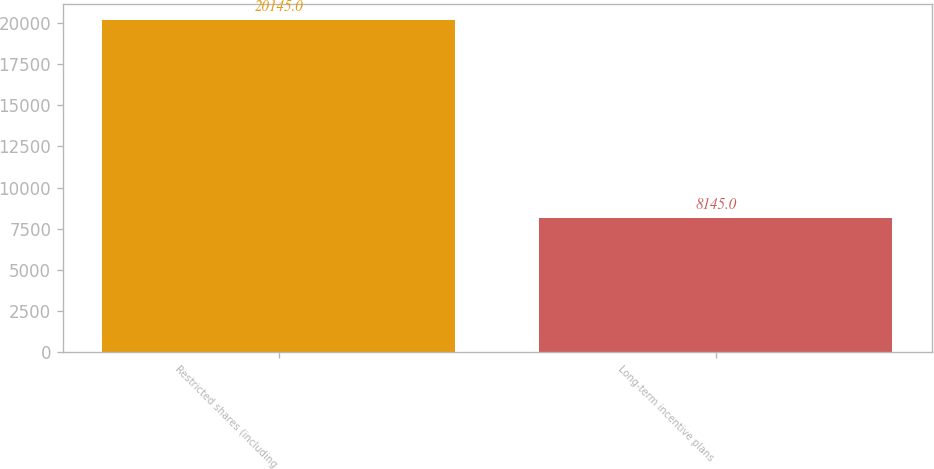Convert chart. <chart><loc_0><loc_0><loc_500><loc_500><bar_chart><fcel>Restricted shares (including<fcel>Long-term incentive plans<nl><fcel>20145<fcel>8145<nl></chart> 